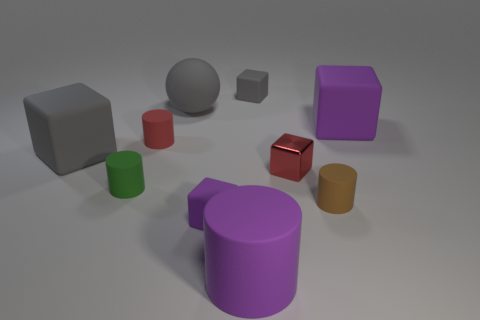Subtract all red cubes. How many cubes are left? 4 Subtract all tiny purple rubber blocks. How many blocks are left? 4 Subtract all green blocks. Subtract all red balls. How many blocks are left? 5 Subtract all cylinders. How many objects are left? 6 Add 2 balls. How many balls exist? 3 Subtract 0 purple spheres. How many objects are left? 10 Subtract all brown metal balls. Subtract all red cylinders. How many objects are left? 9 Add 2 small green cylinders. How many small green cylinders are left? 3 